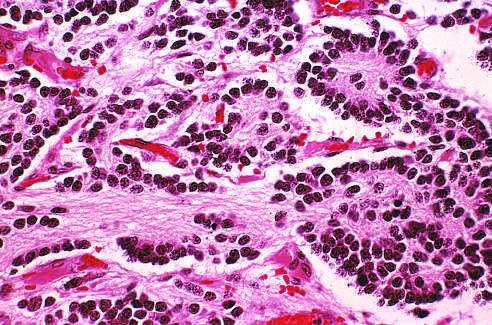what is seen in the upper right corner?
Answer the question using a single word or phrase. A homer-wright pseudorosette 